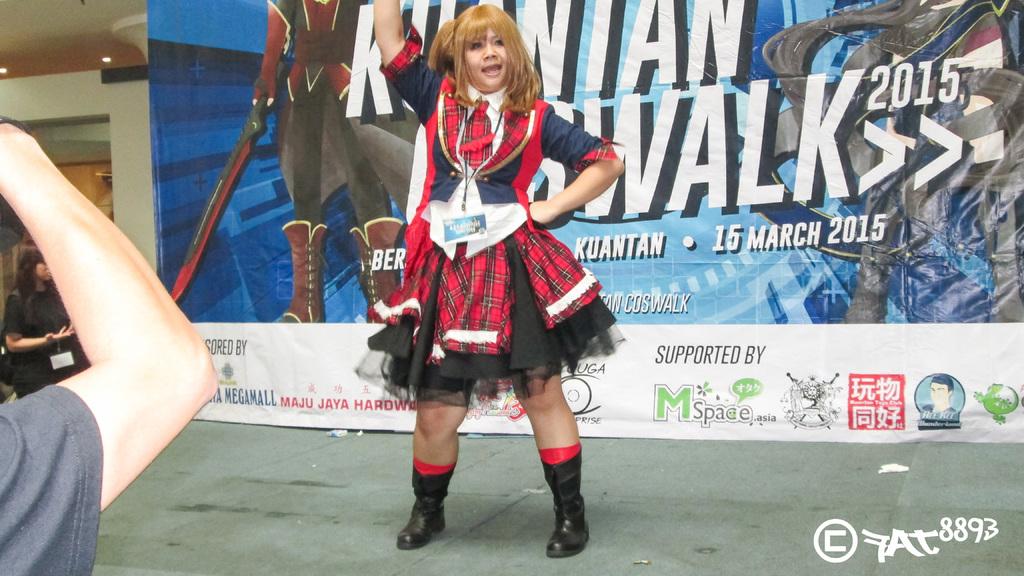What is the date of the event?
Give a very brief answer. 15 march 2015. Name one brand this is supported by?
Your response must be concise. Mspace. 